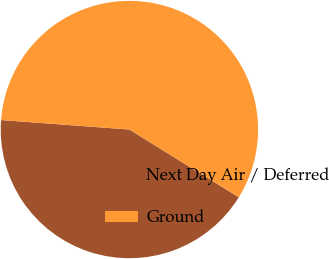Convert chart. <chart><loc_0><loc_0><loc_500><loc_500><pie_chart><fcel>Next Day Air / Deferred<fcel>Ground<nl><fcel>42.35%<fcel>57.65%<nl></chart> 